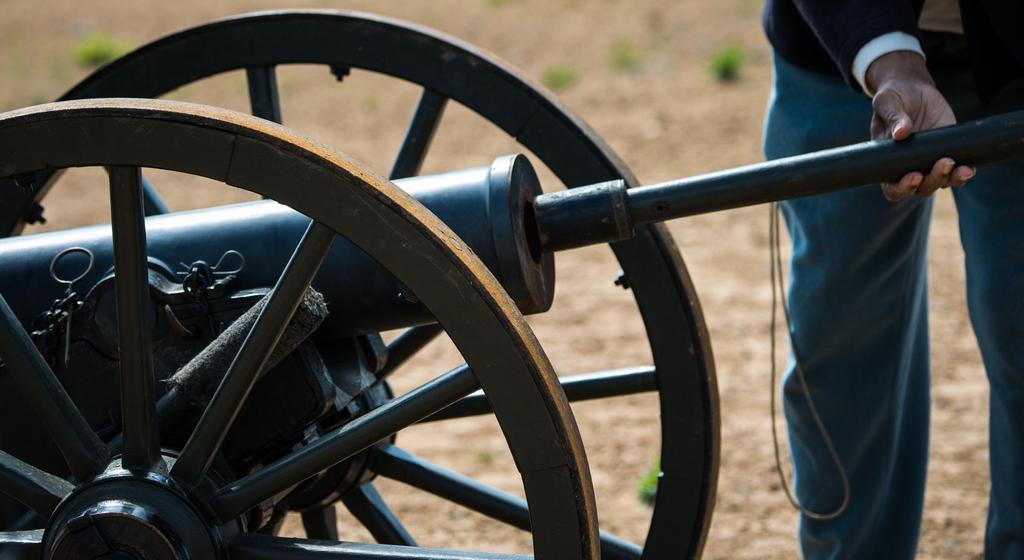How would you summarize this image in a sentence or two? In the foreground, I can see a person is holding a metal rod in hand and I can see metal wheels on the ground. In the background, I can see grass. This picture might be taken in a day. 